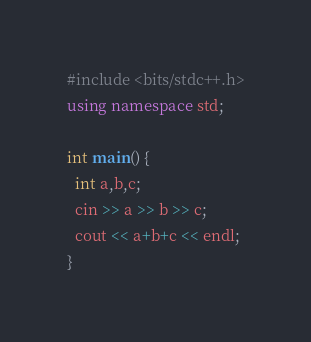Convert code to text. <code><loc_0><loc_0><loc_500><loc_500><_C++_>#include <bits/stdc++.h>
using namespace std;
 
int main() {
  int a,b,c;
  cin >> a >> b >> c;
  cout << a+b+c << endl;
}</code> 